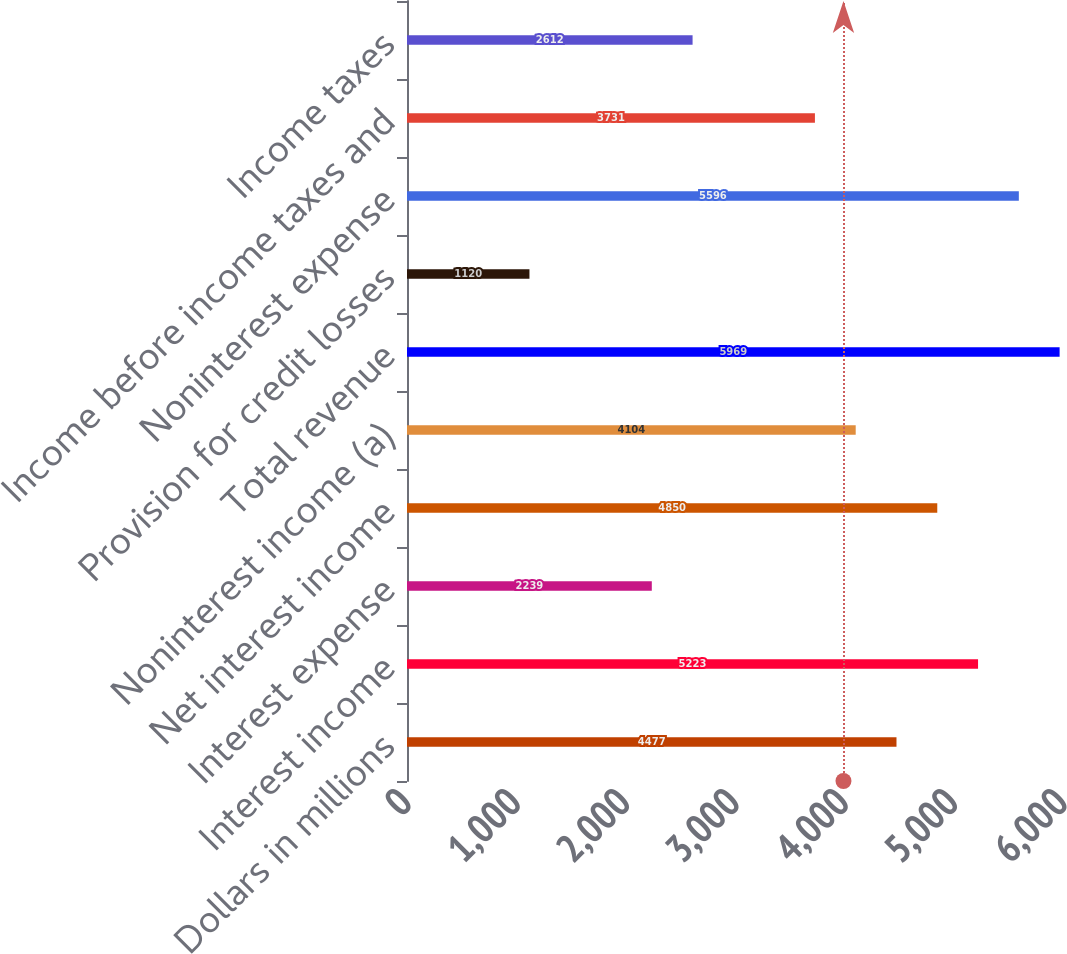Convert chart to OTSL. <chart><loc_0><loc_0><loc_500><loc_500><bar_chart><fcel>Dollars in millions<fcel>Interest income<fcel>Interest expense<fcel>Net interest income<fcel>Noninterest income (a)<fcel>Total revenue<fcel>Provision for credit losses<fcel>Noninterest expense<fcel>Income before income taxes and<fcel>Income taxes<nl><fcel>4477<fcel>5223<fcel>2239<fcel>4850<fcel>4104<fcel>5969<fcel>1120<fcel>5596<fcel>3731<fcel>2612<nl></chart> 